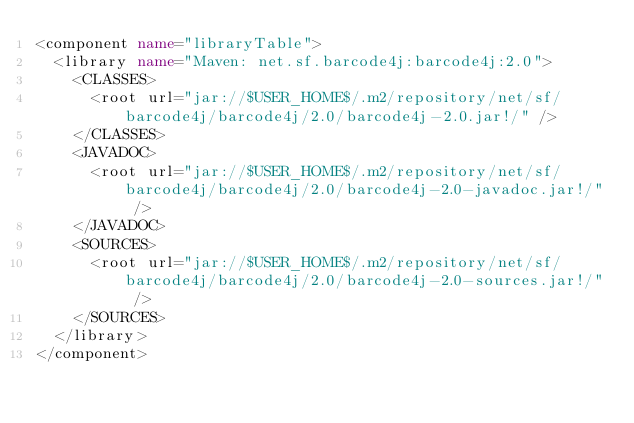Convert code to text. <code><loc_0><loc_0><loc_500><loc_500><_XML_><component name="libraryTable">
  <library name="Maven: net.sf.barcode4j:barcode4j:2.0">
    <CLASSES>
      <root url="jar://$USER_HOME$/.m2/repository/net/sf/barcode4j/barcode4j/2.0/barcode4j-2.0.jar!/" />
    </CLASSES>
    <JAVADOC>
      <root url="jar://$USER_HOME$/.m2/repository/net/sf/barcode4j/barcode4j/2.0/barcode4j-2.0-javadoc.jar!/" />
    </JAVADOC>
    <SOURCES>
      <root url="jar://$USER_HOME$/.m2/repository/net/sf/barcode4j/barcode4j/2.0/barcode4j-2.0-sources.jar!/" />
    </SOURCES>
  </library>
</component></code> 